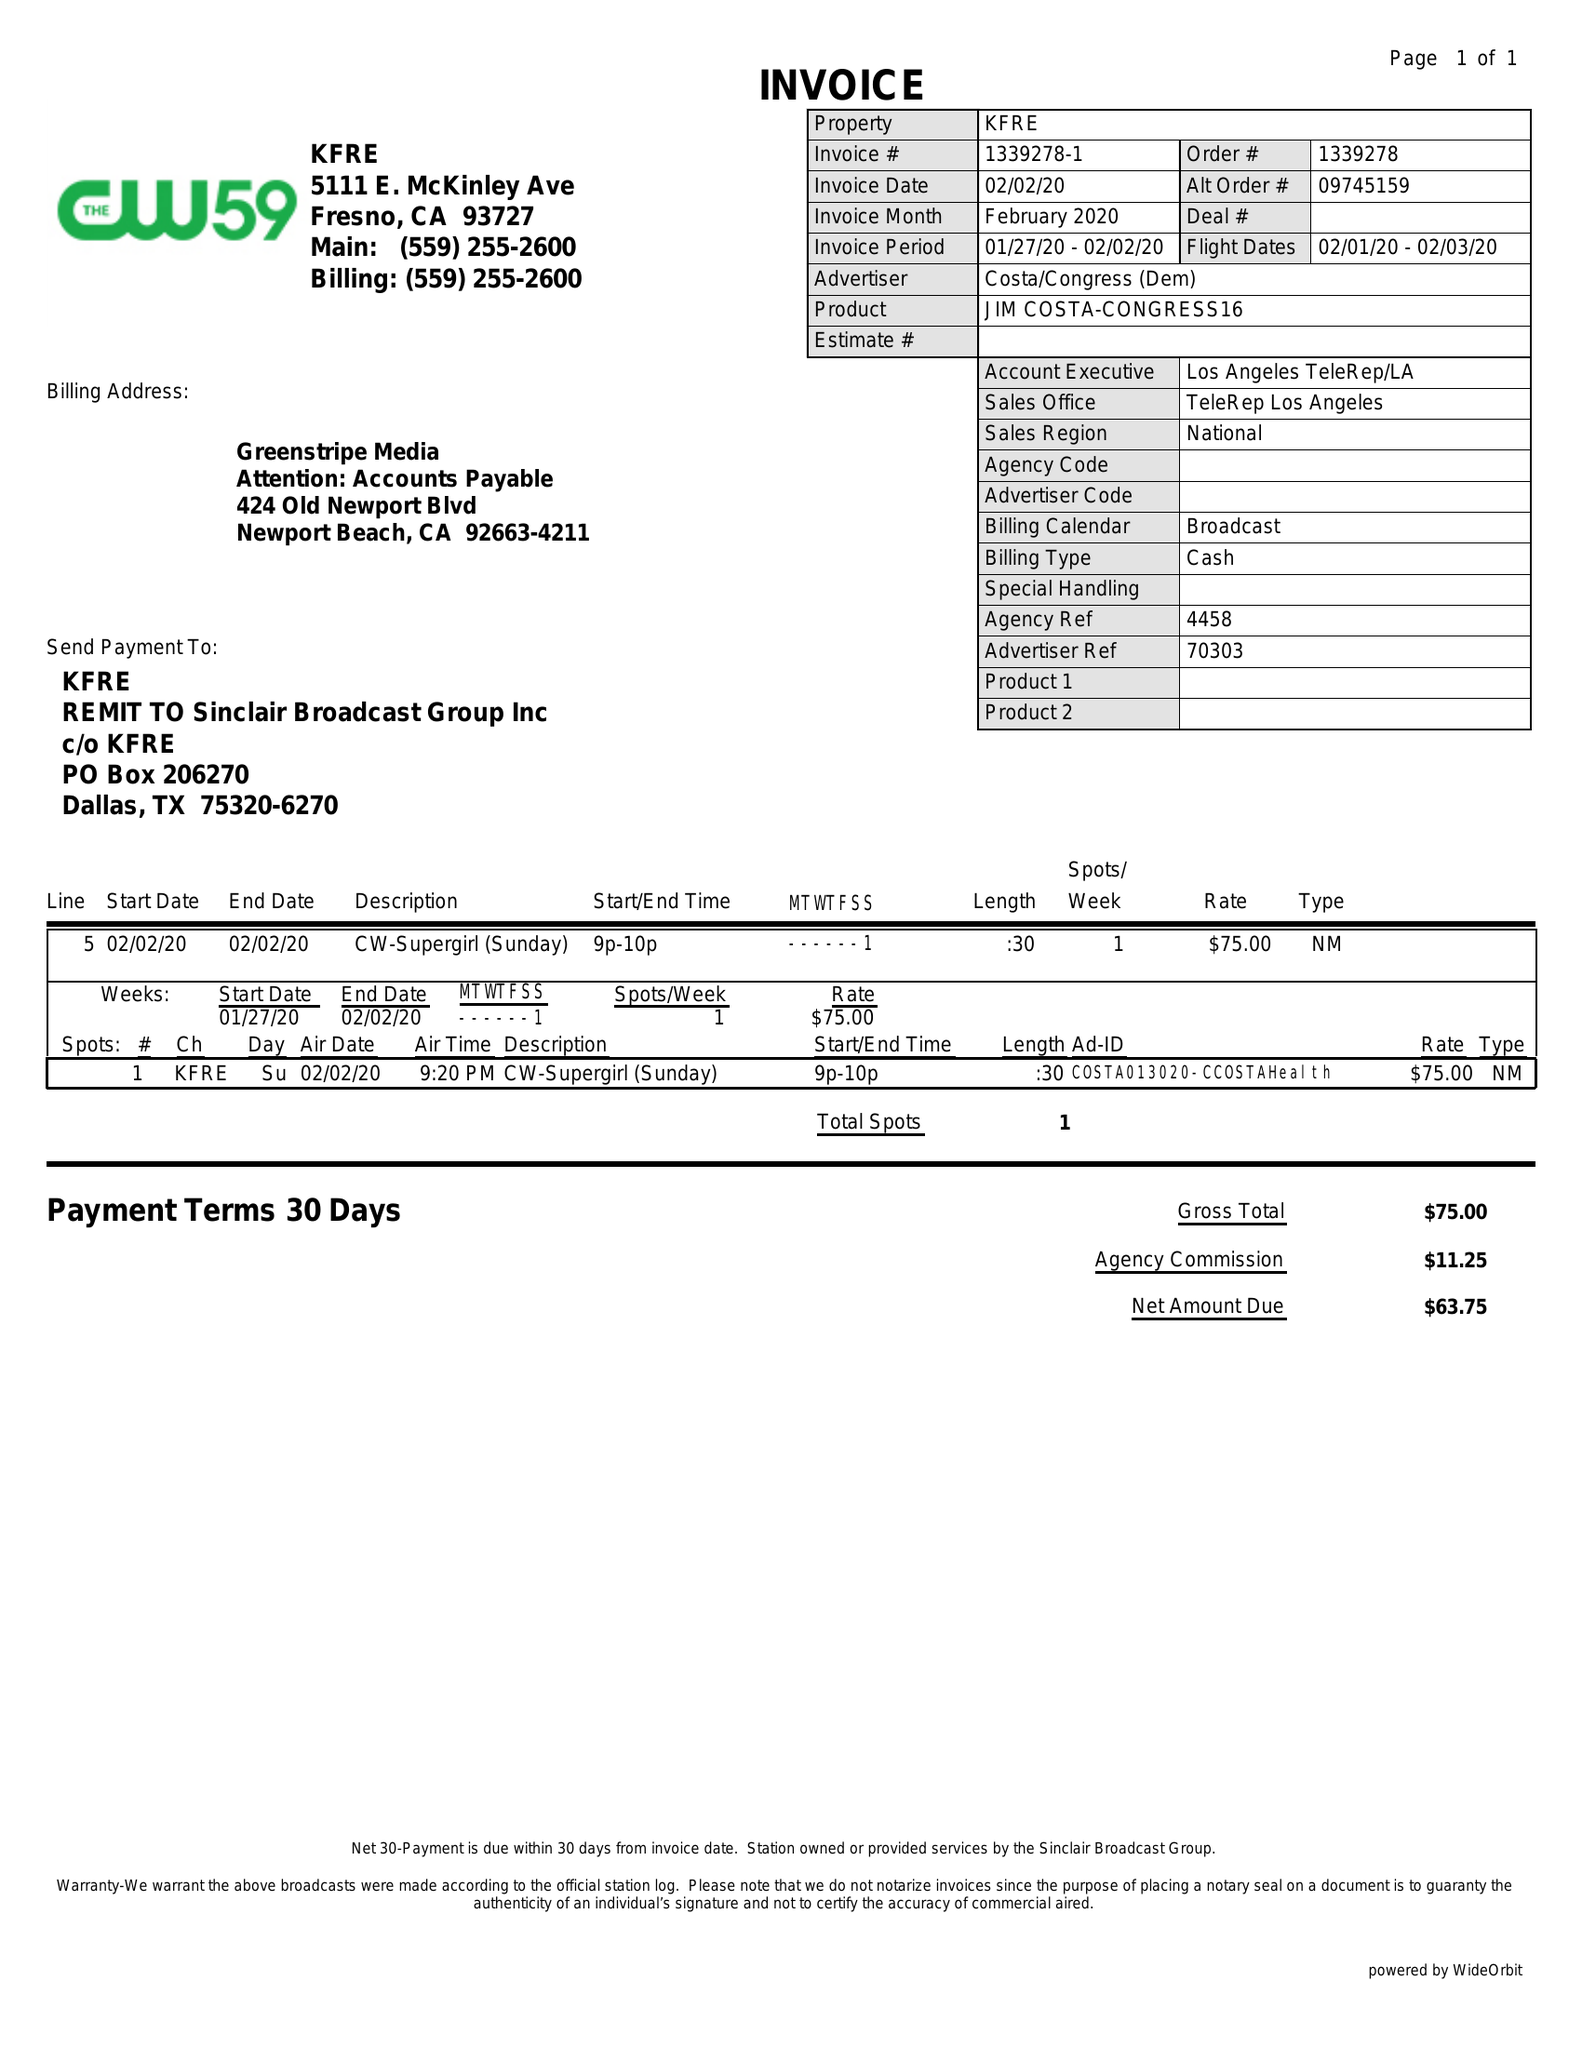What is the value for the contract_num?
Answer the question using a single word or phrase. 1339278 